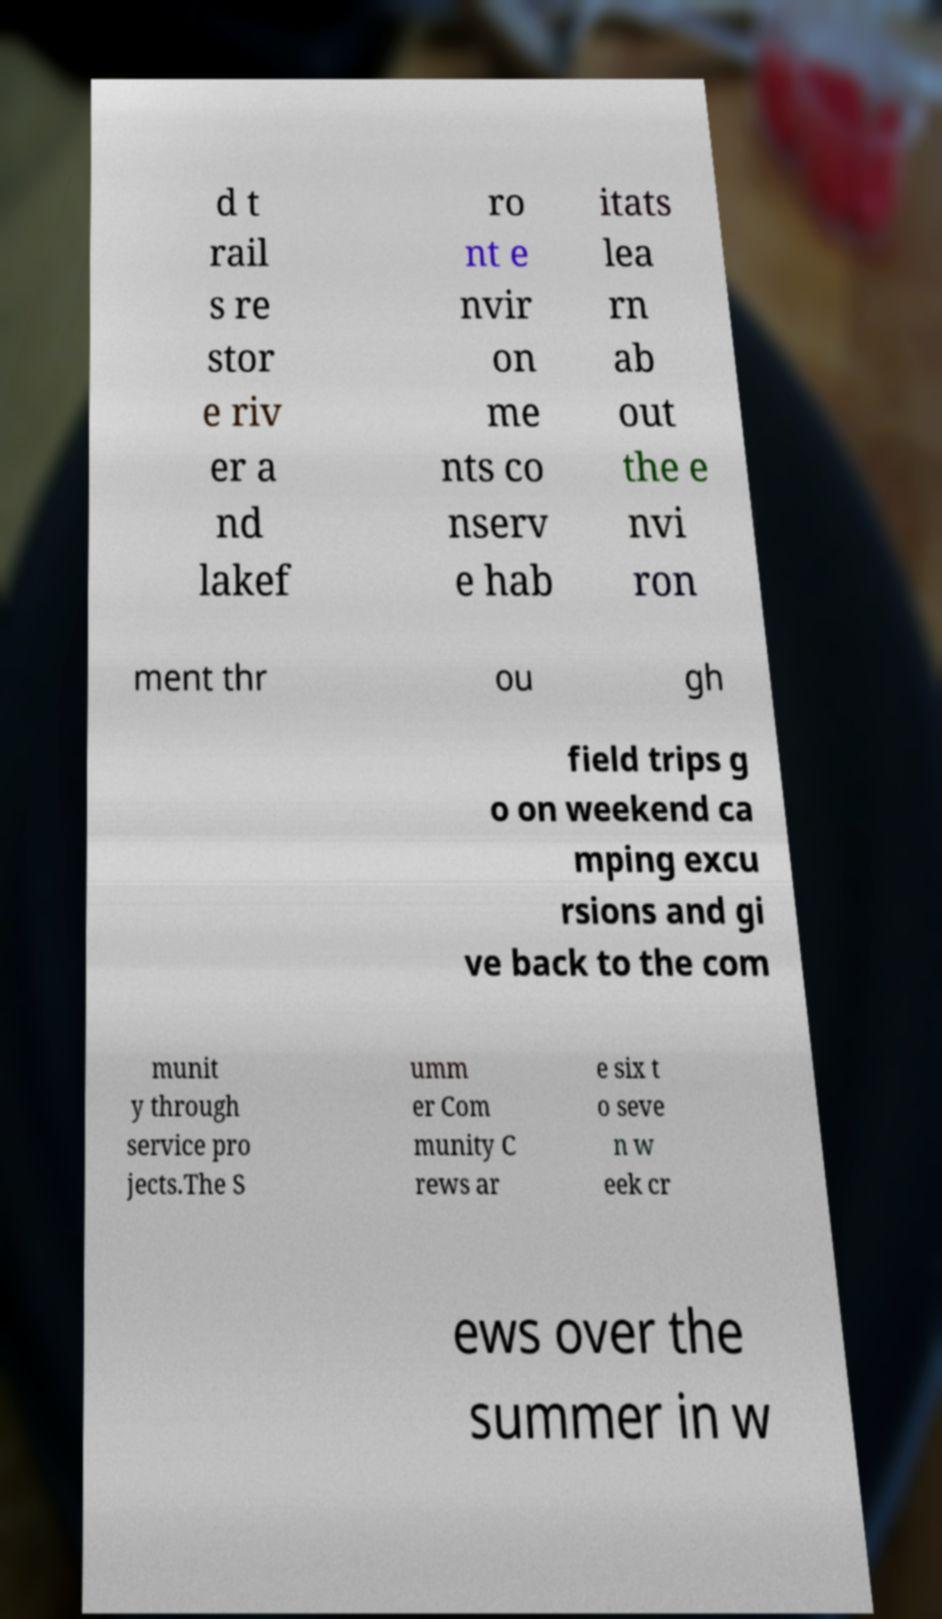Could you assist in decoding the text presented in this image and type it out clearly? d t rail s re stor e riv er a nd lakef ro nt e nvir on me nts co nserv e hab itats lea rn ab out the e nvi ron ment thr ou gh field trips g o on weekend ca mping excu rsions and gi ve back to the com munit y through service pro jects.The S umm er Com munity C rews ar e six t o seve n w eek cr ews over the summer in w 